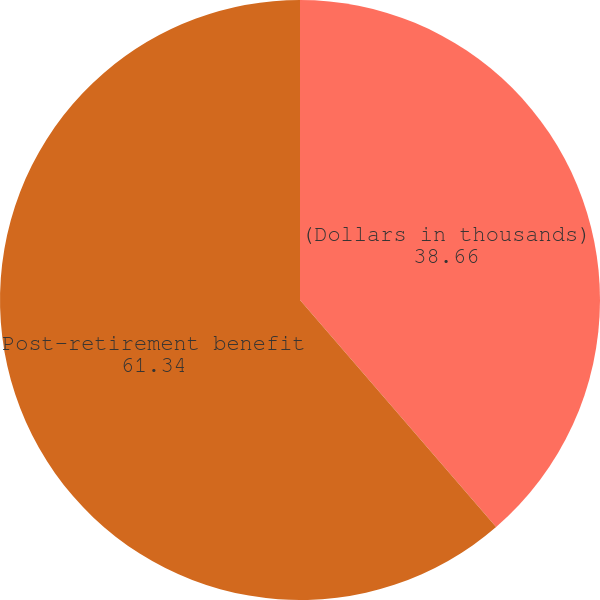Convert chart. <chart><loc_0><loc_0><loc_500><loc_500><pie_chart><fcel>(Dollars in thousands)<fcel>Post-retirement benefit<nl><fcel>38.66%<fcel>61.34%<nl></chart> 